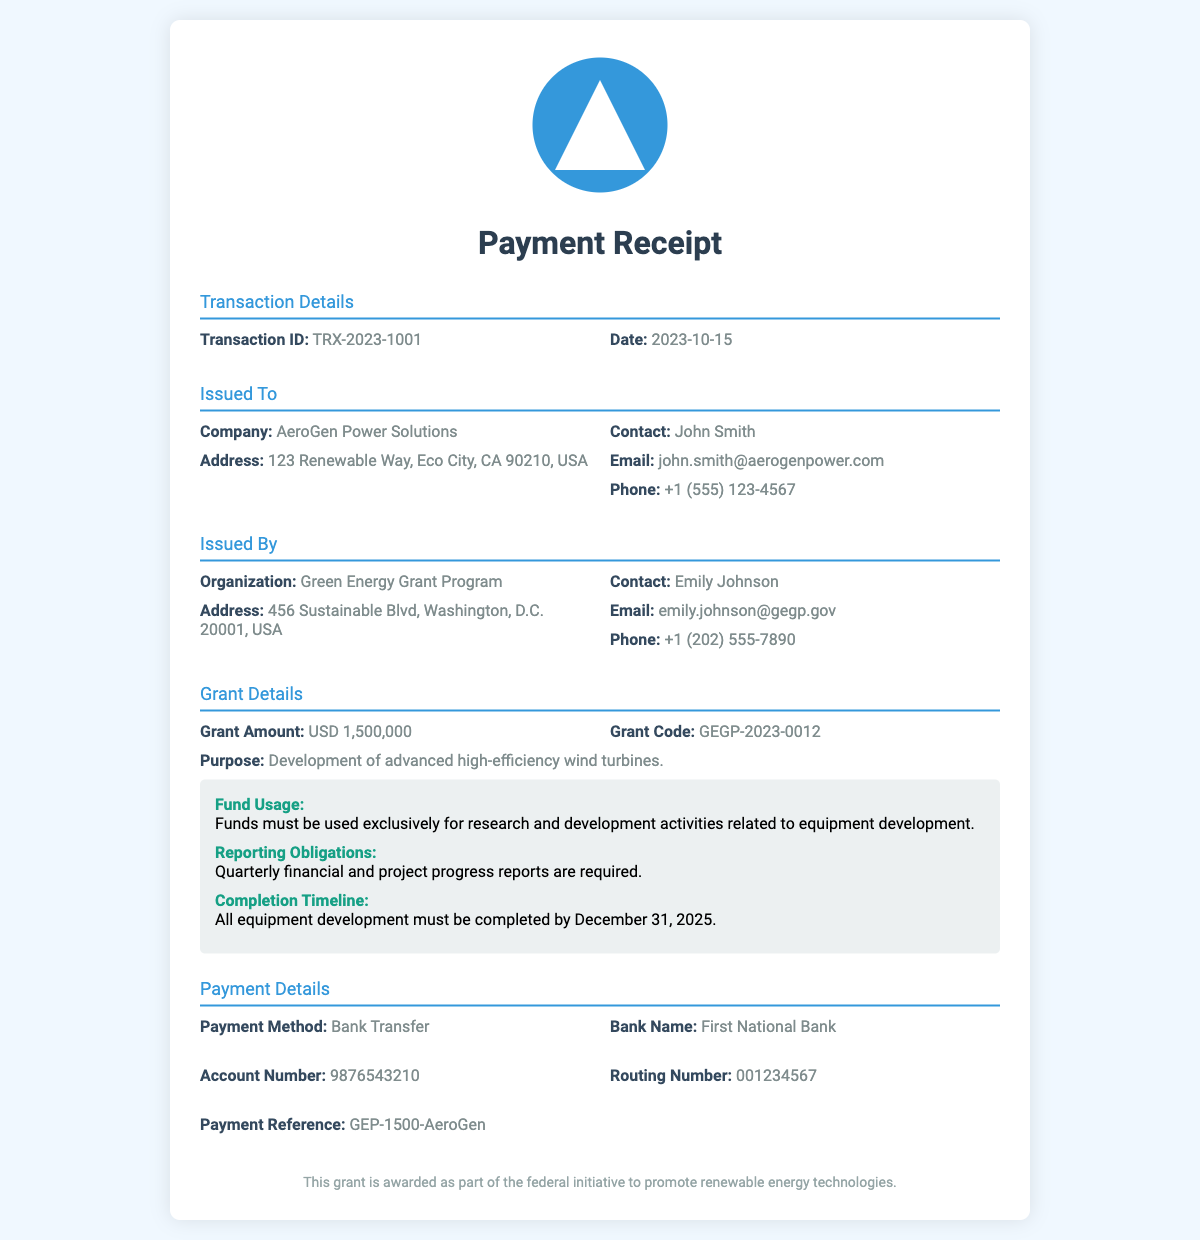What is the grant amount? The grant amount is specified in the Grant Details section of the document.
Answer: USD 1,500,000 What is the transaction ID? The transaction ID can be found in the Transaction Details section.
Answer: TRX-2023-1001 Who issued this payment receipt? The organization that issued the payment receipt is listed in the Issued By section.
Answer: Green Energy Grant Program What is the purpose of the grant? The purpose of the grant is mentioned under Grant Details.
Answer: Development of advanced high-efficiency wind turbines What is the completion timeline for the project? The completion timeline is stated in the grant terms within the Grant Details section.
Answer: December 31, 2025 What is the payment method used? The payment method is detailed in the Payment Details section.
Answer: Bank Transfer Who is the contact person for AeroGen Power Solutions? The contact person is specified in the Issued To section.
Answer: John Smith What are the reporting obligations? The reporting obligations are included in the grant terms section.
Answer: Quarterly financial and project progress reports are required What is the bank name for the payment? The bank name is found in the Payment Details section.
Answer: First National Bank 